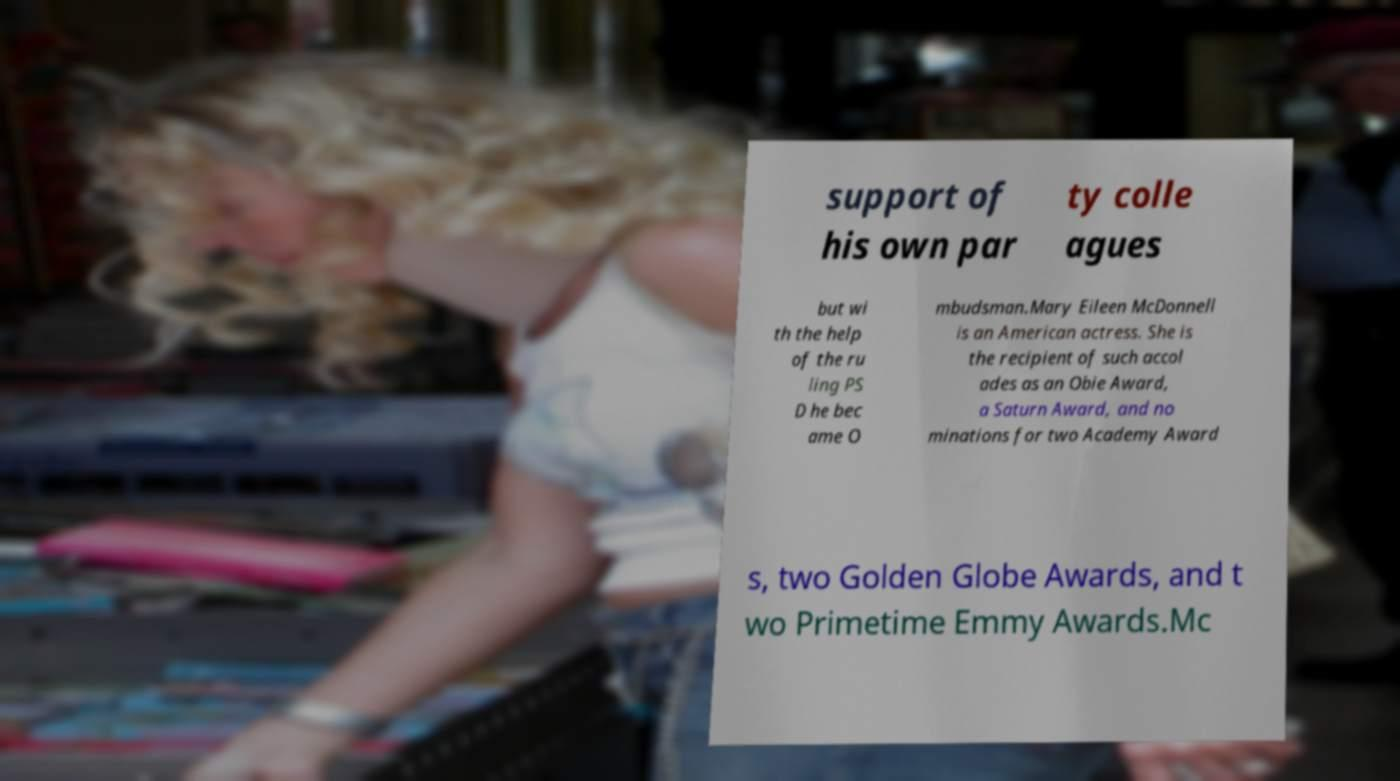Can you read and provide the text displayed in the image?This photo seems to have some interesting text. Can you extract and type it out for me? support of his own par ty colle agues but wi th the help of the ru ling PS D he bec ame O mbudsman.Mary Eileen McDonnell is an American actress. She is the recipient of such accol ades as an Obie Award, a Saturn Award, and no minations for two Academy Award s, two Golden Globe Awards, and t wo Primetime Emmy Awards.Mc 